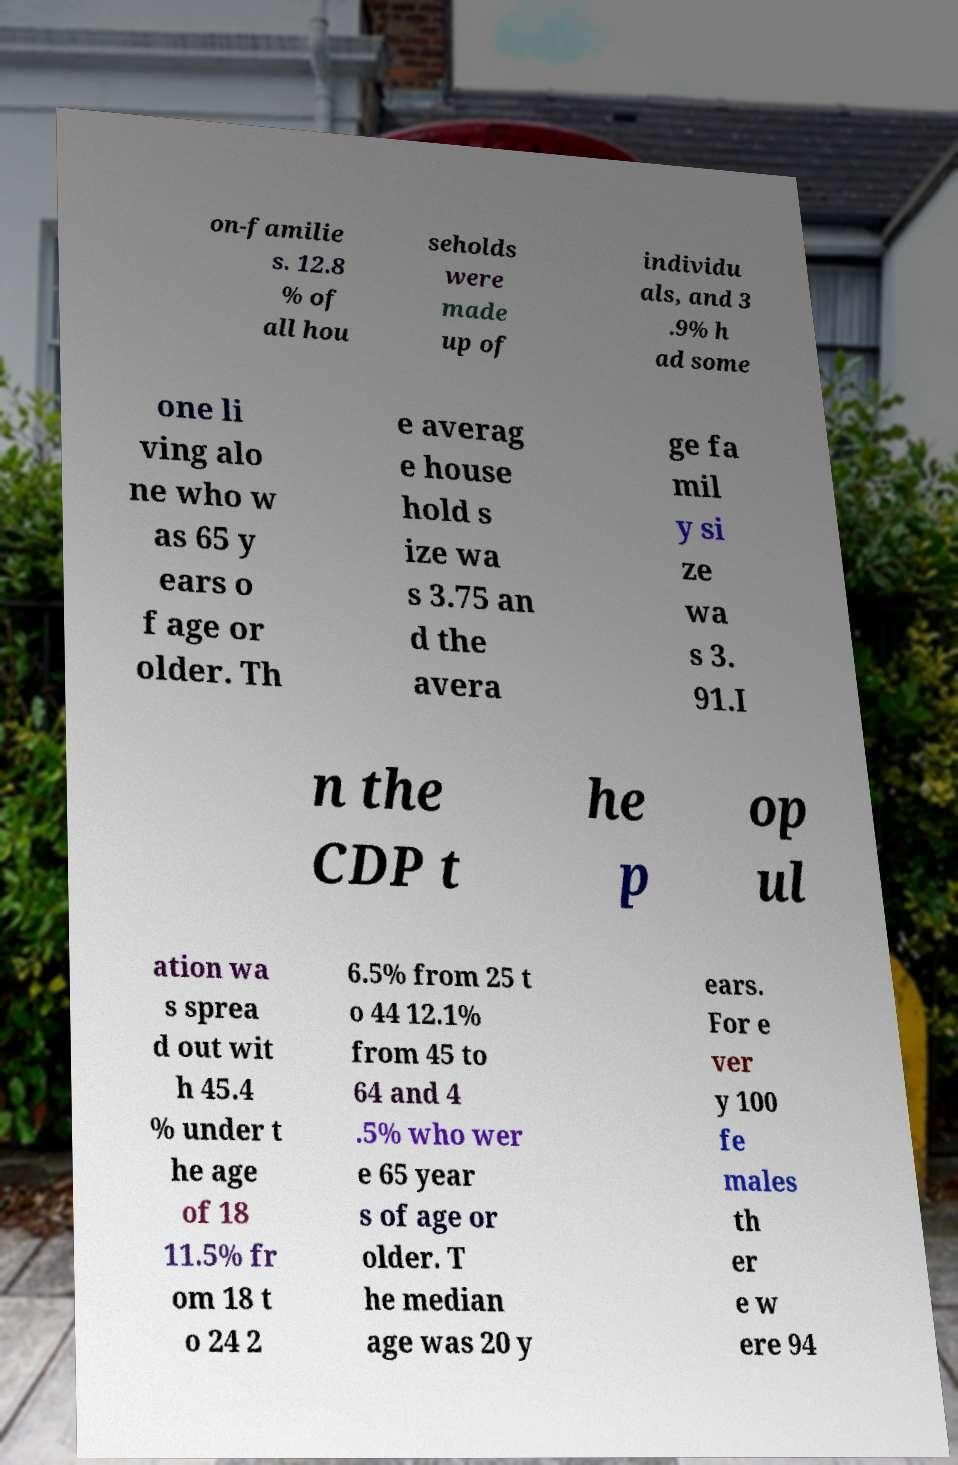There's text embedded in this image that I need extracted. Can you transcribe it verbatim? on-familie s. 12.8 % of all hou seholds were made up of individu als, and 3 .9% h ad some one li ving alo ne who w as 65 y ears o f age or older. Th e averag e house hold s ize wa s 3.75 an d the avera ge fa mil y si ze wa s 3. 91.I n the CDP t he p op ul ation wa s sprea d out wit h 45.4 % under t he age of 18 11.5% fr om 18 t o 24 2 6.5% from 25 t o 44 12.1% from 45 to 64 and 4 .5% who wer e 65 year s of age or older. T he median age was 20 y ears. For e ver y 100 fe males th er e w ere 94 